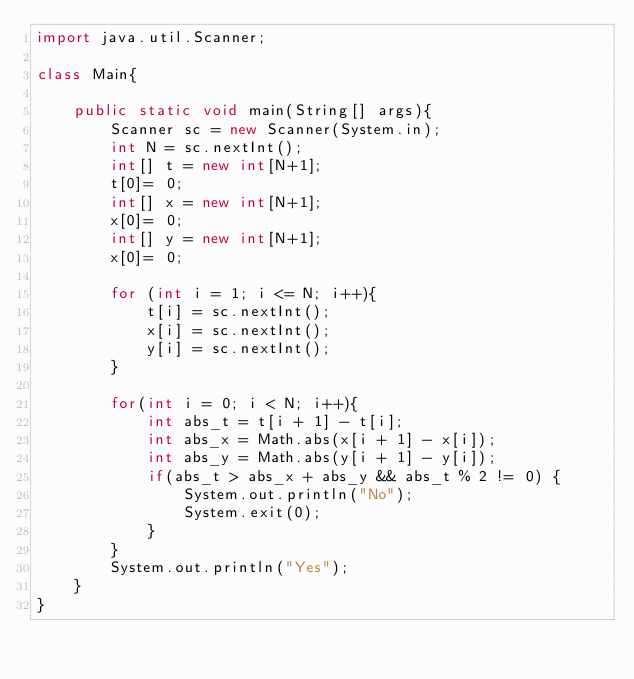<code> <loc_0><loc_0><loc_500><loc_500><_Java_>import java.util.Scanner;

class Main{

    public static void main(String[] args){
        Scanner sc = new Scanner(System.in);
        int N = sc.nextInt();
        int[] t = new int[N+1];
        t[0]= 0;
        int[] x = new int[N+1];
        x[0]= 0;
        int[] y = new int[N+1];
        x[0]= 0;
        
        for (int i = 1; i <= N; i++){
            t[i] = sc.nextInt();
            x[i] = sc.nextInt();
            y[i] = sc.nextInt();
        }

        for(int i = 0; i < N; i++){
            int abs_t = t[i + 1] - t[i];
            int abs_x = Math.abs(x[i + 1] - x[i]);
            int abs_y = Math.abs(y[i + 1] - y[i]);
            if(abs_t > abs_x + abs_y && abs_t % 2 != 0) {
                System.out.println("No");
                System.exit(0);
            } 
        }
        System.out.println("Yes");
    }
}
</code> 